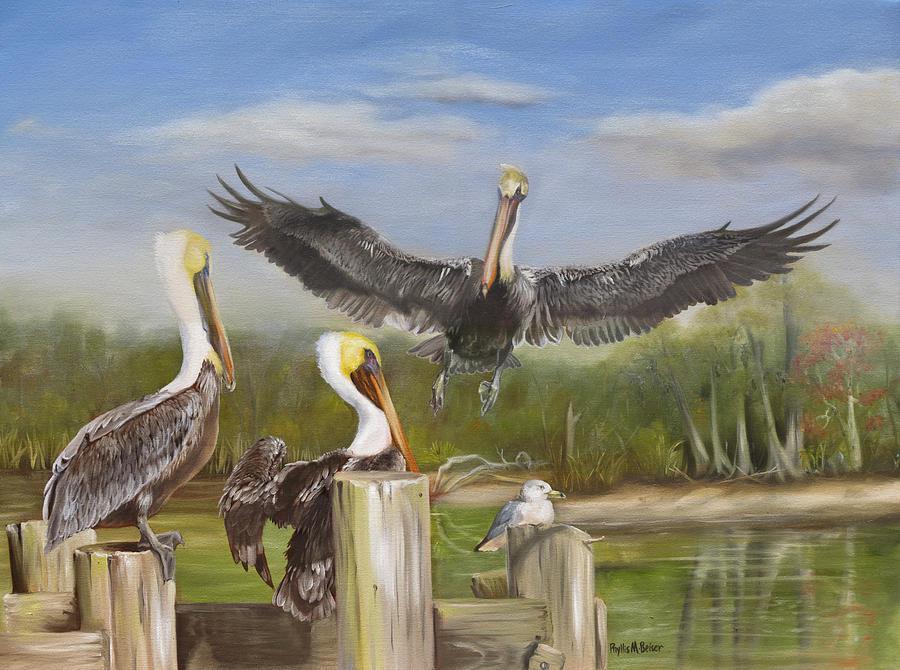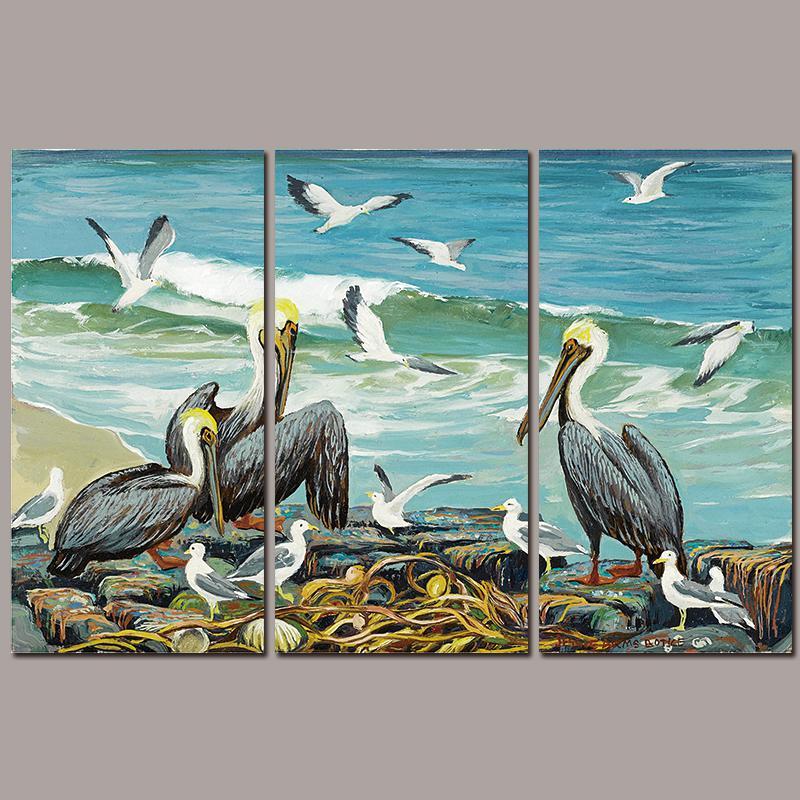The first image is the image on the left, the second image is the image on the right. Considering the images on both sides, is "One image includes a pelican and a smaller seabird perched on some part of a wooden pier." valid? Answer yes or no. Yes. 